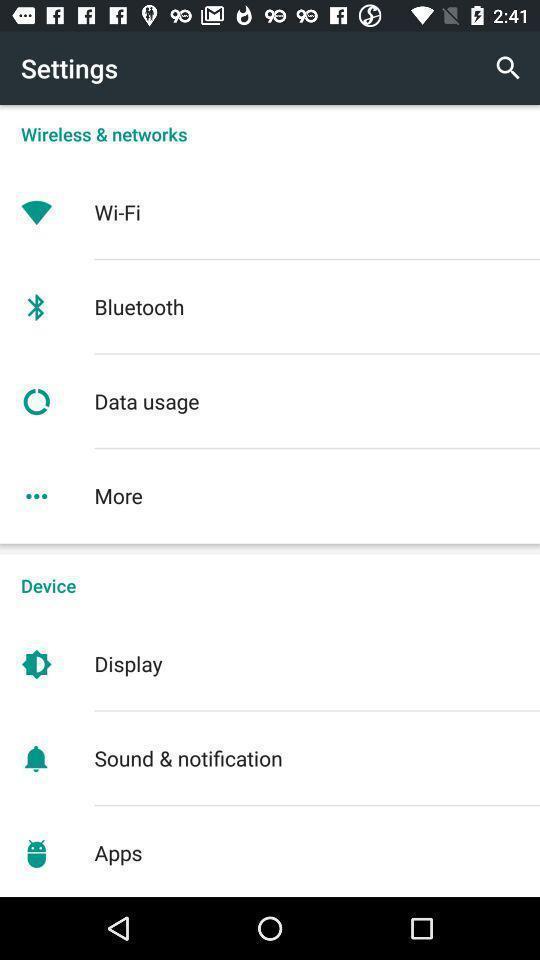Summarize the information in this screenshot. Screen showing settings page. 